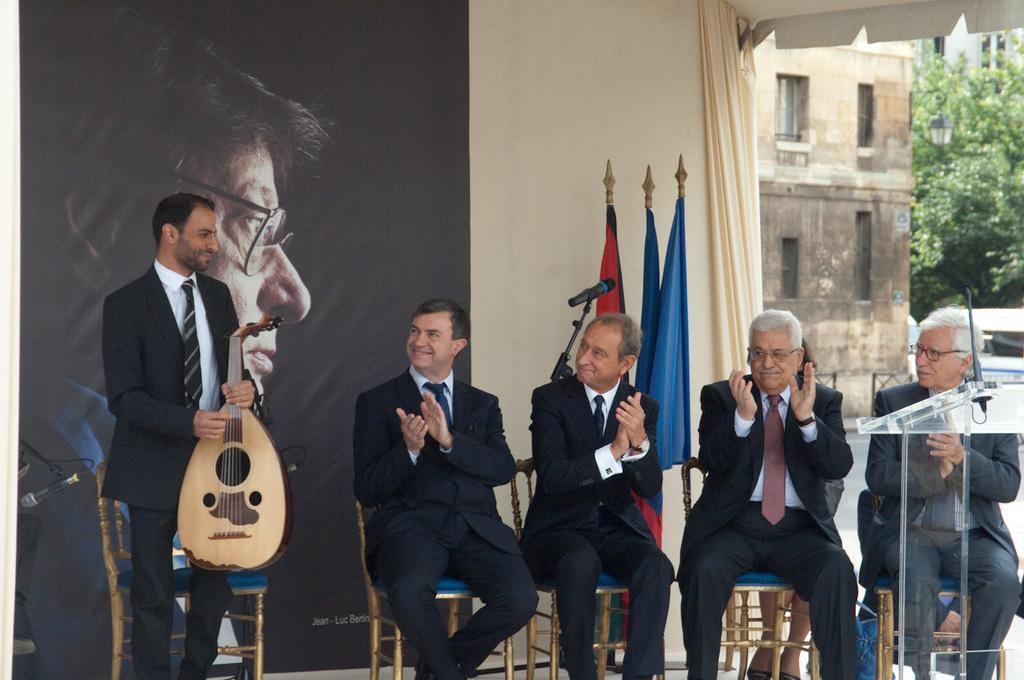In one or two sentences, can you explain what this image depicts? This image is clicked in a program where there are 5 man in this image. Right side the tree on the top and a building. There is a curtain on the right side. 4 men are sitting and one man is standing he is holding a musical instrument. There are 5 chairs in this image there is a man Mike. There are three flags in this image. Behind them there is a picture of one man, there is a podium in the right side and there is mic attached to that podium. 